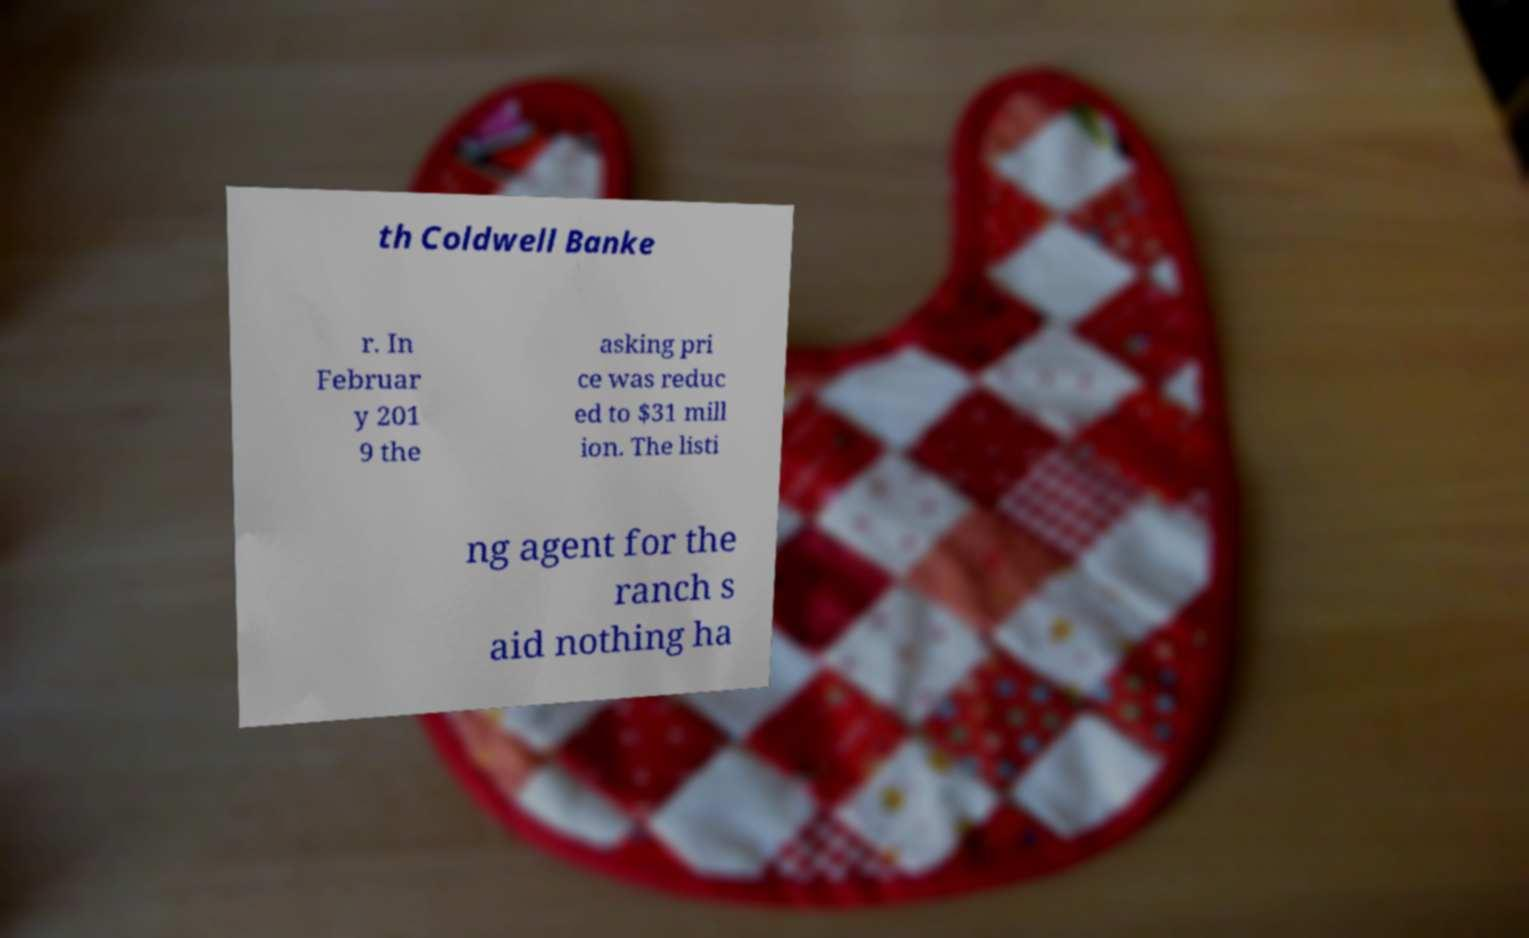Can you read and provide the text displayed in the image?This photo seems to have some interesting text. Can you extract and type it out for me? th Coldwell Banke r. In Februar y 201 9 the asking pri ce was reduc ed to $31 mill ion. The listi ng agent for the ranch s aid nothing ha 